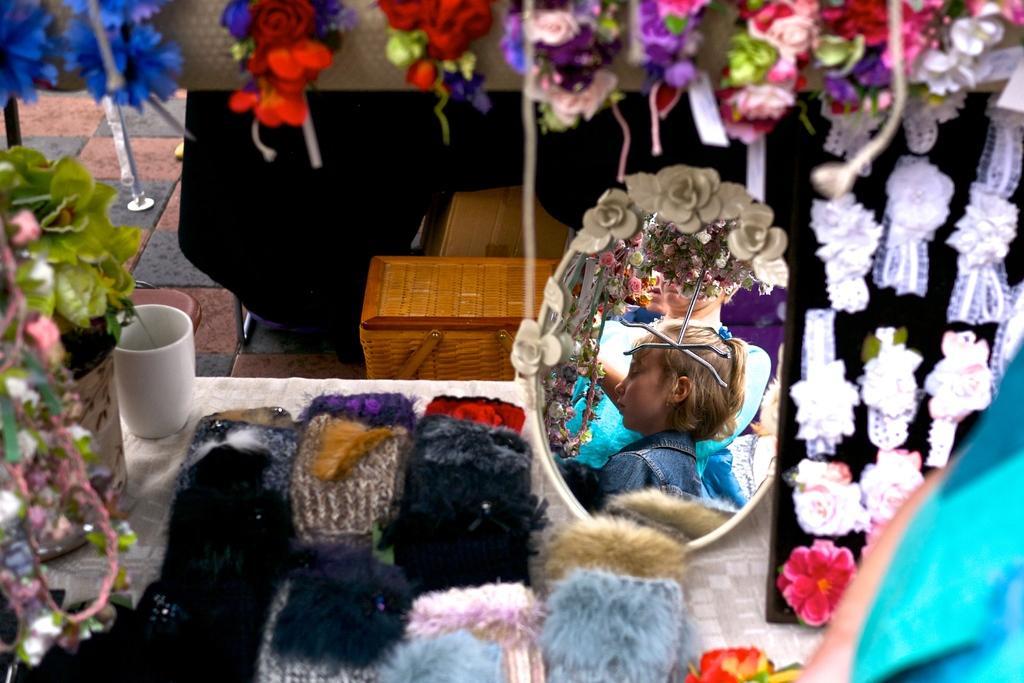In one or two sentences, can you explain what this image depicts? In this image I can see the black and brown colored floor, brown colored wooden basket, a white colored table. On the table I can see a cup, a flower vase with a plant, few objects and a mirror. In the mirror I can see the reflection of few persons. I can see few white colored headbands and few other objects which are red, white, pink, blue and green in color. 